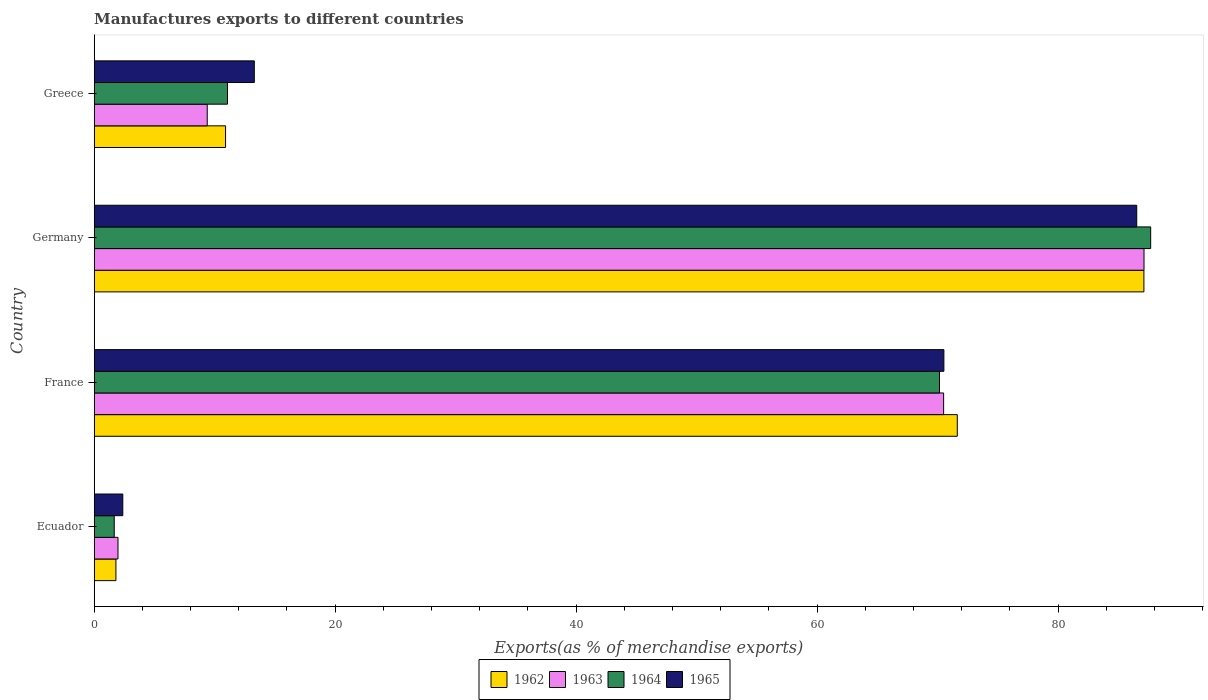How many different coloured bars are there?
Offer a terse response. 4. Are the number of bars per tick equal to the number of legend labels?
Your response must be concise. Yes. Are the number of bars on each tick of the Y-axis equal?
Keep it short and to the point. Yes. How many bars are there on the 3rd tick from the top?
Provide a succinct answer. 4. What is the label of the 4th group of bars from the top?
Provide a succinct answer. Ecuador. In how many cases, is the number of bars for a given country not equal to the number of legend labels?
Give a very brief answer. 0. What is the percentage of exports to different countries in 1965 in Greece?
Your response must be concise. 13.29. Across all countries, what is the maximum percentage of exports to different countries in 1963?
Ensure brevity in your answer.  87.13. Across all countries, what is the minimum percentage of exports to different countries in 1962?
Your answer should be very brief. 1.8. In which country was the percentage of exports to different countries in 1962 maximum?
Ensure brevity in your answer.  Germany. In which country was the percentage of exports to different countries in 1965 minimum?
Your response must be concise. Ecuador. What is the total percentage of exports to different countries in 1964 in the graph?
Ensure brevity in your answer.  170.57. What is the difference between the percentage of exports to different countries in 1962 in Germany and that in Greece?
Make the answer very short. 76.22. What is the difference between the percentage of exports to different countries in 1963 in Greece and the percentage of exports to different countries in 1962 in Germany?
Your answer should be very brief. -77.74. What is the average percentage of exports to different countries in 1965 per country?
Offer a very short reply. 43.18. What is the difference between the percentage of exports to different countries in 1964 and percentage of exports to different countries in 1962 in Greece?
Provide a short and direct response. 0.16. What is the ratio of the percentage of exports to different countries in 1965 in France to that in Germany?
Your answer should be very brief. 0.82. What is the difference between the highest and the second highest percentage of exports to different countries in 1963?
Keep it short and to the point. 16.63. What is the difference between the highest and the lowest percentage of exports to different countries in 1964?
Ensure brevity in your answer.  86.02. Is the sum of the percentage of exports to different countries in 1964 in France and Germany greater than the maximum percentage of exports to different countries in 1965 across all countries?
Provide a short and direct response. Yes. Is it the case that in every country, the sum of the percentage of exports to different countries in 1963 and percentage of exports to different countries in 1965 is greater than the sum of percentage of exports to different countries in 1964 and percentage of exports to different countries in 1962?
Provide a succinct answer. No. What does the 1st bar from the top in Germany represents?
Offer a terse response. 1965. What does the 3rd bar from the bottom in Germany represents?
Offer a very short reply. 1964. Is it the case that in every country, the sum of the percentage of exports to different countries in 1964 and percentage of exports to different countries in 1965 is greater than the percentage of exports to different countries in 1963?
Ensure brevity in your answer.  Yes. How many bars are there?
Ensure brevity in your answer.  16. Are all the bars in the graph horizontal?
Provide a short and direct response. Yes. Are the values on the major ticks of X-axis written in scientific E-notation?
Provide a short and direct response. No. Does the graph contain any zero values?
Your answer should be very brief. No. How many legend labels are there?
Your answer should be very brief. 4. What is the title of the graph?
Your answer should be very brief. Manufactures exports to different countries. Does "1980" appear as one of the legend labels in the graph?
Give a very brief answer. No. What is the label or title of the X-axis?
Offer a terse response. Exports(as % of merchandise exports). What is the Exports(as % of merchandise exports) in 1962 in Ecuador?
Make the answer very short. 1.8. What is the Exports(as % of merchandise exports) of 1963 in Ecuador?
Your answer should be very brief. 1.97. What is the Exports(as % of merchandise exports) of 1964 in Ecuador?
Offer a very short reply. 1.66. What is the Exports(as % of merchandise exports) of 1965 in Ecuador?
Your answer should be very brief. 2.37. What is the Exports(as % of merchandise exports) in 1962 in France?
Offer a very short reply. 71.64. What is the Exports(as % of merchandise exports) in 1963 in France?
Your answer should be very brief. 70.5. What is the Exports(as % of merchandise exports) of 1964 in France?
Your response must be concise. 70.16. What is the Exports(as % of merchandise exports) of 1965 in France?
Keep it short and to the point. 70.52. What is the Exports(as % of merchandise exports) of 1962 in Germany?
Ensure brevity in your answer.  87.12. What is the Exports(as % of merchandise exports) in 1963 in Germany?
Your answer should be compact. 87.13. What is the Exports(as % of merchandise exports) in 1964 in Germany?
Your answer should be compact. 87.69. What is the Exports(as % of merchandise exports) of 1965 in Germany?
Your answer should be very brief. 86.53. What is the Exports(as % of merchandise exports) in 1962 in Greece?
Ensure brevity in your answer.  10.9. What is the Exports(as % of merchandise exports) in 1963 in Greece?
Provide a short and direct response. 9.38. What is the Exports(as % of merchandise exports) in 1964 in Greece?
Provide a succinct answer. 11.06. What is the Exports(as % of merchandise exports) of 1965 in Greece?
Make the answer very short. 13.29. Across all countries, what is the maximum Exports(as % of merchandise exports) of 1962?
Ensure brevity in your answer.  87.12. Across all countries, what is the maximum Exports(as % of merchandise exports) of 1963?
Make the answer very short. 87.13. Across all countries, what is the maximum Exports(as % of merchandise exports) in 1964?
Your answer should be compact. 87.69. Across all countries, what is the maximum Exports(as % of merchandise exports) of 1965?
Make the answer very short. 86.53. Across all countries, what is the minimum Exports(as % of merchandise exports) of 1962?
Provide a short and direct response. 1.8. Across all countries, what is the minimum Exports(as % of merchandise exports) in 1963?
Provide a short and direct response. 1.97. Across all countries, what is the minimum Exports(as % of merchandise exports) of 1964?
Give a very brief answer. 1.66. Across all countries, what is the minimum Exports(as % of merchandise exports) in 1965?
Keep it short and to the point. 2.37. What is the total Exports(as % of merchandise exports) of 1962 in the graph?
Your answer should be very brief. 171.47. What is the total Exports(as % of merchandise exports) in 1963 in the graph?
Offer a terse response. 168.99. What is the total Exports(as % of merchandise exports) of 1964 in the graph?
Give a very brief answer. 170.57. What is the total Exports(as % of merchandise exports) in 1965 in the graph?
Your answer should be compact. 172.71. What is the difference between the Exports(as % of merchandise exports) in 1962 in Ecuador and that in France?
Provide a short and direct response. -69.83. What is the difference between the Exports(as % of merchandise exports) of 1963 in Ecuador and that in France?
Offer a very short reply. -68.53. What is the difference between the Exports(as % of merchandise exports) of 1964 in Ecuador and that in France?
Your response must be concise. -68.5. What is the difference between the Exports(as % of merchandise exports) of 1965 in Ecuador and that in France?
Your answer should be very brief. -68.15. What is the difference between the Exports(as % of merchandise exports) in 1962 in Ecuador and that in Germany?
Your answer should be very brief. -85.32. What is the difference between the Exports(as % of merchandise exports) in 1963 in Ecuador and that in Germany?
Your response must be concise. -85.16. What is the difference between the Exports(as % of merchandise exports) in 1964 in Ecuador and that in Germany?
Your answer should be compact. -86.02. What is the difference between the Exports(as % of merchandise exports) in 1965 in Ecuador and that in Germany?
Your response must be concise. -84.15. What is the difference between the Exports(as % of merchandise exports) in 1962 in Ecuador and that in Greece?
Your answer should be very brief. -9.1. What is the difference between the Exports(as % of merchandise exports) in 1963 in Ecuador and that in Greece?
Provide a succinct answer. -7.41. What is the difference between the Exports(as % of merchandise exports) in 1964 in Ecuador and that in Greece?
Ensure brevity in your answer.  -9.4. What is the difference between the Exports(as % of merchandise exports) of 1965 in Ecuador and that in Greece?
Your answer should be compact. -10.91. What is the difference between the Exports(as % of merchandise exports) of 1962 in France and that in Germany?
Your answer should be compact. -15.49. What is the difference between the Exports(as % of merchandise exports) in 1963 in France and that in Germany?
Your answer should be compact. -16.63. What is the difference between the Exports(as % of merchandise exports) of 1964 in France and that in Germany?
Your response must be concise. -17.53. What is the difference between the Exports(as % of merchandise exports) of 1965 in France and that in Germany?
Your answer should be compact. -16.01. What is the difference between the Exports(as % of merchandise exports) in 1962 in France and that in Greece?
Your answer should be compact. 60.73. What is the difference between the Exports(as % of merchandise exports) of 1963 in France and that in Greece?
Your response must be concise. 61.12. What is the difference between the Exports(as % of merchandise exports) in 1964 in France and that in Greece?
Provide a short and direct response. 59.1. What is the difference between the Exports(as % of merchandise exports) in 1965 in France and that in Greece?
Make the answer very short. 57.23. What is the difference between the Exports(as % of merchandise exports) of 1962 in Germany and that in Greece?
Offer a terse response. 76.22. What is the difference between the Exports(as % of merchandise exports) in 1963 in Germany and that in Greece?
Keep it short and to the point. 77.75. What is the difference between the Exports(as % of merchandise exports) of 1964 in Germany and that in Greece?
Give a very brief answer. 76.62. What is the difference between the Exports(as % of merchandise exports) of 1965 in Germany and that in Greece?
Provide a succinct answer. 73.24. What is the difference between the Exports(as % of merchandise exports) of 1962 in Ecuador and the Exports(as % of merchandise exports) of 1963 in France?
Ensure brevity in your answer.  -68.7. What is the difference between the Exports(as % of merchandise exports) of 1962 in Ecuador and the Exports(as % of merchandise exports) of 1964 in France?
Your answer should be compact. -68.35. What is the difference between the Exports(as % of merchandise exports) in 1962 in Ecuador and the Exports(as % of merchandise exports) in 1965 in France?
Offer a very short reply. -68.72. What is the difference between the Exports(as % of merchandise exports) of 1963 in Ecuador and the Exports(as % of merchandise exports) of 1964 in France?
Offer a terse response. -68.18. What is the difference between the Exports(as % of merchandise exports) in 1963 in Ecuador and the Exports(as % of merchandise exports) in 1965 in France?
Make the answer very short. -68.55. What is the difference between the Exports(as % of merchandise exports) of 1964 in Ecuador and the Exports(as % of merchandise exports) of 1965 in France?
Your answer should be very brief. -68.86. What is the difference between the Exports(as % of merchandise exports) in 1962 in Ecuador and the Exports(as % of merchandise exports) in 1963 in Germany?
Ensure brevity in your answer.  -85.33. What is the difference between the Exports(as % of merchandise exports) of 1962 in Ecuador and the Exports(as % of merchandise exports) of 1964 in Germany?
Keep it short and to the point. -85.88. What is the difference between the Exports(as % of merchandise exports) in 1962 in Ecuador and the Exports(as % of merchandise exports) in 1965 in Germany?
Make the answer very short. -84.72. What is the difference between the Exports(as % of merchandise exports) in 1963 in Ecuador and the Exports(as % of merchandise exports) in 1964 in Germany?
Make the answer very short. -85.71. What is the difference between the Exports(as % of merchandise exports) of 1963 in Ecuador and the Exports(as % of merchandise exports) of 1965 in Germany?
Provide a short and direct response. -84.55. What is the difference between the Exports(as % of merchandise exports) of 1964 in Ecuador and the Exports(as % of merchandise exports) of 1965 in Germany?
Your response must be concise. -84.87. What is the difference between the Exports(as % of merchandise exports) of 1962 in Ecuador and the Exports(as % of merchandise exports) of 1963 in Greece?
Give a very brief answer. -7.58. What is the difference between the Exports(as % of merchandise exports) of 1962 in Ecuador and the Exports(as % of merchandise exports) of 1964 in Greece?
Keep it short and to the point. -9.26. What is the difference between the Exports(as % of merchandise exports) in 1962 in Ecuador and the Exports(as % of merchandise exports) in 1965 in Greece?
Provide a short and direct response. -11.48. What is the difference between the Exports(as % of merchandise exports) in 1963 in Ecuador and the Exports(as % of merchandise exports) in 1964 in Greece?
Your answer should be very brief. -9.09. What is the difference between the Exports(as % of merchandise exports) in 1963 in Ecuador and the Exports(as % of merchandise exports) in 1965 in Greece?
Ensure brevity in your answer.  -11.31. What is the difference between the Exports(as % of merchandise exports) of 1964 in Ecuador and the Exports(as % of merchandise exports) of 1965 in Greece?
Offer a very short reply. -11.63. What is the difference between the Exports(as % of merchandise exports) in 1962 in France and the Exports(as % of merchandise exports) in 1963 in Germany?
Keep it short and to the point. -15.5. What is the difference between the Exports(as % of merchandise exports) in 1962 in France and the Exports(as % of merchandise exports) in 1964 in Germany?
Provide a short and direct response. -16.05. What is the difference between the Exports(as % of merchandise exports) in 1962 in France and the Exports(as % of merchandise exports) in 1965 in Germany?
Make the answer very short. -14.89. What is the difference between the Exports(as % of merchandise exports) in 1963 in France and the Exports(as % of merchandise exports) in 1964 in Germany?
Offer a terse response. -17.18. What is the difference between the Exports(as % of merchandise exports) in 1963 in France and the Exports(as % of merchandise exports) in 1965 in Germany?
Offer a very short reply. -16.03. What is the difference between the Exports(as % of merchandise exports) in 1964 in France and the Exports(as % of merchandise exports) in 1965 in Germany?
Give a very brief answer. -16.37. What is the difference between the Exports(as % of merchandise exports) of 1962 in France and the Exports(as % of merchandise exports) of 1963 in Greece?
Your answer should be compact. 62.25. What is the difference between the Exports(as % of merchandise exports) in 1962 in France and the Exports(as % of merchandise exports) in 1964 in Greece?
Ensure brevity in your answer.  60.57. What is the difference between the Exports(as % of merchandise exports) in 1962 in France and the Exports(as % of merchandise exports) in 1965 in Greece?
Give a very brief answer. 58.35. What is the difference between the Exports(as % of merchandise exports) of 1963 in France and the Exports(as % of merchandise exports) of 1964 in Greece?
Offer a very short reply. 59.44. What is the difference between the Exports(as % of merchandise exports) of 1963 in France and the Exports(as % of merchandise exports) of 1965 in Greece?
Ensure brevity in your answer.  57.21. What is the difference between the Exports(as % of merchandise exports) of 1964 in France and the Exports(as % of merchandise exports) of 1965 in Greece?
Your answer should be very brief. 56.87. What is the difference between the Exports(as % of merchandise exports) in 1962 in Germany and the Exports(as % of merchandise exports) in 1963 in Greece?
Provide a succinct answer. 77.74. What is the difference between the Exports(as % of merchandise exports) of 1962 in Germany and the Exports(as % of merchandise exports) of 1964 in Greece?
Your answer should be very brief. 76.06. What is the difference between the Exports(as % of merchandise exports) of 1962 in Germany and the Exports(as % of merchandise exports) of 1965 in Greece?
Your answer should be very brief. 73.84. What is the difference between the Exports(as % of merchandise exports) in 1963 in Germany and the Exports(as % of merchandise exports) in 1964 in Greece?
Give a very brief answer. 76.07. What is the difference between the Exports(as % of merchandise exports) in 1963 in Germany and the Exports(as % of merchandise exports) in 1965 in Greece?
Ensure brevity in your answer.  73.84. What is the difference between the Exports(as % of merchandise exports) in 1964 in Germany and the Exports(as % of merchandise exports) in 1965 in Greece?
Your answer should be compact. 74.4. What is the average Exports(as % of merchandise exports) in 1962 per country?
Your answer should be compact. 42.87. What is the average Exports(as % of merchandise exports) in 1963 per country?
Give a very brief answer. 42.25. What is the average Exports(as % of merchandise exports) of 1964 per country?
Provide a short and direct response. 42.64. What is the average Exports(as % of merchandise exports) of 1965 per country?
Your answer should be compact. 43.18. What is the difference between the Exports(as % of merchandise exports) in 1962 and Exports(as % of merchandise exports) in 1963 in Ecuador?
Give a very brief answer. -0.17. What is the difference between the Exports(as % of merchandise exports) of 1962 and Exports(as % of merchandise exports) of 1964 in Ecuador?
Make the answer very short. 0.14. What is the difference between the Exports(as % of merchandise exports) of 1962 and Exports(as % of merchandise exports) of 1965 in Ecuador?
Provide a short and direct response. -0.57. What is the difference between the Exports(as % of merchandise exports) in 1963 and Exports(as % of merchandise exports) in 1964 in Ecuador?
Your answer should be very brief. 0.31. What is the difference between the Exports(as % of merchandise exports) in 1963 and Exports(as % of merchandise exports) in 1965 in Ecuador?
Offer a terse response. -0.4. What is the difference between the Exports(as % of merchandise exports) of 1964 and Exports(as % of merchandise exports) of 1965 in Ecuador?
Offer a terse response. -0.71. What is the difference between the Exports(as % of merchandise exports) of 1962 and Exports(as % of merchandise exports) of 1963 in France?
Your answer should be compact. 1.13. What is the difference between the Exports(as % of merchandise exports) in 1962 and Exports(as % of merchandise exports) in 1964 in France?
Your response must be concise. 1.48. What is the difference between the Exports(as % of merchandise exports) of 1962 and Exports(as % of merchandise exports) of 1965 in France?
Your answer should be very brief. 1.11. What is the difference between the Exports(as % of merchandise exports) of 1963 and Exports(as % of merchandise exports) of 1964 in France?
Your answer should be compact. 0.34. What is the difference between the Exports(as % of merchandise exports) in 1963 and Exports(as % of merchandise exports) in 1965 in France?
Offer a terse response. -0.02. What is the difference between the Exports(as % of merchandise exports) of 1964 and Exports(as % of merchandise exports) of 1965 in France?
Give a very brief answer. -0.36. What is the difference between the Exports(as % of merchandise exports) of 1962 and Exports(as % of merchandise exports) of 1963 in Germany?
Offer a terse response. -0.01. What is the difference between the Exports(as % of merchandise exports) in 1962 and Exports(as % of merchandise exports) in 1964 in Germany?
Give a very brief answer. -0.56. What is the difference between the Exports(as % of merchandise exports) in 1962 and Exports(as % of merchandise exports) in 1965 in Germany?
Give a very brief answer. 0.6. What is the difference between the Exports(as % of merchandise exports) in 1963 and Exports(as % of merchandise exports) in 1964 in Germany?
Offer a terse response. -0.55. What is the difference between the Exports(as % of merchandise exports) of 1963 and Exports(as % of merchandise exports) of 1965 in Germany?
Offer a terse response. 0.6. What is the difference between the Exports(as % of merchandise exports) of 1964 and Exports(as % of merchandise exports) of 1965 in Germany?
Give a very brief answer. 1.16. What is the difference between the Exports(as % of merchandise exports) in 1962 and Exports(as % of merchandise exports) in 1963 in Greece?
Your response must be concise. 1.52. What is the difference between the Exports(as % of merchandise exports) of 1962 and Exports(as % of merchandise exports) of 1964 in Greece?
Your answer should be very brief. -0.16. What is the difference between the Exports(as % of merchandise exports) of 1962 and Exports(as % of merchandise exports) of 1965 in Greece?
Ensure brevity in your answer.  -2.39. What is the difference between the Exports(as % of merchandise exports) in 1963 and Exports(as % of merchandise exports) in 1964 in Greece?
Offer a terse response. -1.68. What is the difference between the Exports(as % of merchandise exports) in 1963 and Exports(as % of merchandise exports) in 1965 in Greece?
Make the answer very short. -3.91. What is the difference between the Exports(as % of merchandise exports) of 1964 and Exports(as % of merchandise exports) of 1965 in Greece?
Offer a terse response. -2.23. What is the ratio of the Exports(as % of merchandise exports) of 1962 in Ecuador to that in France?
Offer a very short reply. 0.03. What is the ratio of the Exports(as % of merchandise exports) of 1963 in Ecuador to that in France?
Keep it short and to the point. 0.03. What is the ratio of the Exports(as % of merchandise exports) of 1964 in Ecuador to that in France?
Give a very brief answer. 0.02. What is the ratio of the Exports(as % of merchandise exports) of 1965 in Ecuador to that in France?
Offer a terse response. 0.03. What is the ratio of the Exports(as % of merchandise exports) in 1962 in Ecuador to that in Germany?
Make the answer very short. 0.02. What is the ratio of the Exports(as % of merchandise exports) of 1963 in Ecuador to that in Germany?
Your answer should be very brief. 0.02. What is the ratio of the Exports(as % of merchandise exports) in 1964 in Ecuador to that in Germany?
Offer a terse response. 0.02. What is the ratio of the Exports(as % of merchandise exports) of 1965 in Ecuador to that in Germany?
Ensure brevity in your answer.  0.03. What is the ratio of the Exports(as % of merchandise exports) in 1962 in Ecuador to that in Greece?
Offer a very short reply. 0.17. What is the ratio of the Exports(as % of merchandise exports) of 1963 in Ecuador to that in Greece?
Your response must be concise. 0.21. What is the ratio of the Exports(as % of merchandise exports) in 1964 in Ecuador to that in Greece?
Your response must be concise. 0.15. What is the ratio of the Exports(as % of merchandise exports) in 1965 in Ecuador to that in Greece?
Offer a very short reply. 0.18. What is the ratio of the Exports(as % of merchandise exports) in 1962 in France to that in Germany?
Ensure brevity in your answer.  0.82. What is the ratio of the Exports(as % of merchandise exports) in 1963 in France to that in Germany?
Your answer should be compact. 0.81. What is the ratio of the Exports(as % of merchandise exports) of 1964 in France to that in Germany?
Make the answer very short. 0.8. What is the ratio of the Exports(as % of merchandise exports) in 1965 in France to that in Germany?
Offer a terse response. 0.81. What is the ratio of the Exports(as % of merchandise exports) of 1962 in France to that in Greece?
Offer a terse response. 6.57. What is the ratio of the Exports(as % of merchandise exports) of 1963 in France to that in Greece?
Provide a succinct answer. 7.51. What is the ratio of the Exports(as % of merchandise exports) of 1964 in France to that in Greece?
Offer a very short reply. 6.34. What is the ratio of the Exports(as % of merchandise exports) in 1965 in France to that in Greece?
Your answer should be very brief. 5.31. What is the ratio of the Exports(as % of merchandise exports) in 1962 in Germany to that in Greece?
Keep it short and to the point. 7.99. What is the ratio of the Exports(as % of merchandise exports) in 1963 in Germany to that in Greece?
Your response must be concise. 9.29. What is the ratio of the Exports(as % of merchandise exports) in 1964 in Germany to that in Greece?
Provide a succinct answer. 7.93. What is the ratio of the Exports(as % of merchandise exports) of 1965 in Germany to that in Greece?
Keep it short and to the point. 6.51. What is the difference between the highest and the second highest Exports(as % of merchandise exports) in 1962?
Provide a succinct answer. 15.49. What is the difference between the highest and the second highest Exports(as % of merchandise exports) of 1963?
Provide a succinct answer. 16.63. What is the difference between the highest and the second highest Exports(as % of merchandise exports) of 1964?
Your answer should be compact. 17.53. What is the difference between the highest and the second highest Exports(as % of merchandise exports) in 1965?
Provide a short and direct response. 16.01. What is the difference between the highest and the lowest Exports(as % of merchandise exports) in 1962?
Ensure brevity in your answer.  85.32. What is the difference between the highest and the lowest Exports(as % of merchandise exports) of 1963?
Provide a short and direct response. 85.16. What is the difference between the highest and the lowest Exports(as % of merchandise exports) in 1964?
Offer a very short reply. 86.02. What is the difference between the highest and the lowest Exports(as % of merchandise exports) of 1965?
Provide a succinct answer. 84.15. 